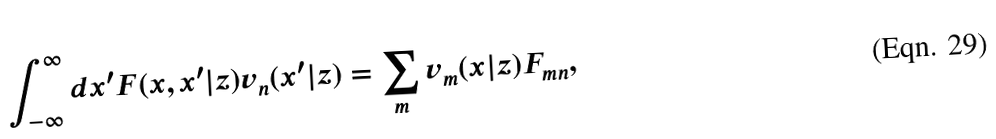Convert formula to latex. <formula><loc_0><loc_0><loc_500><loc_500>\int ^ { \infty } _ { - \infty } d x ^ { \prime } F ( x , x ^ { \prime } | z ) v _ { n } ( x ^ { \prime } | z ) = \sum _ { m } v _ { m } ( x | z ) F _ { m n } ,</formula> 